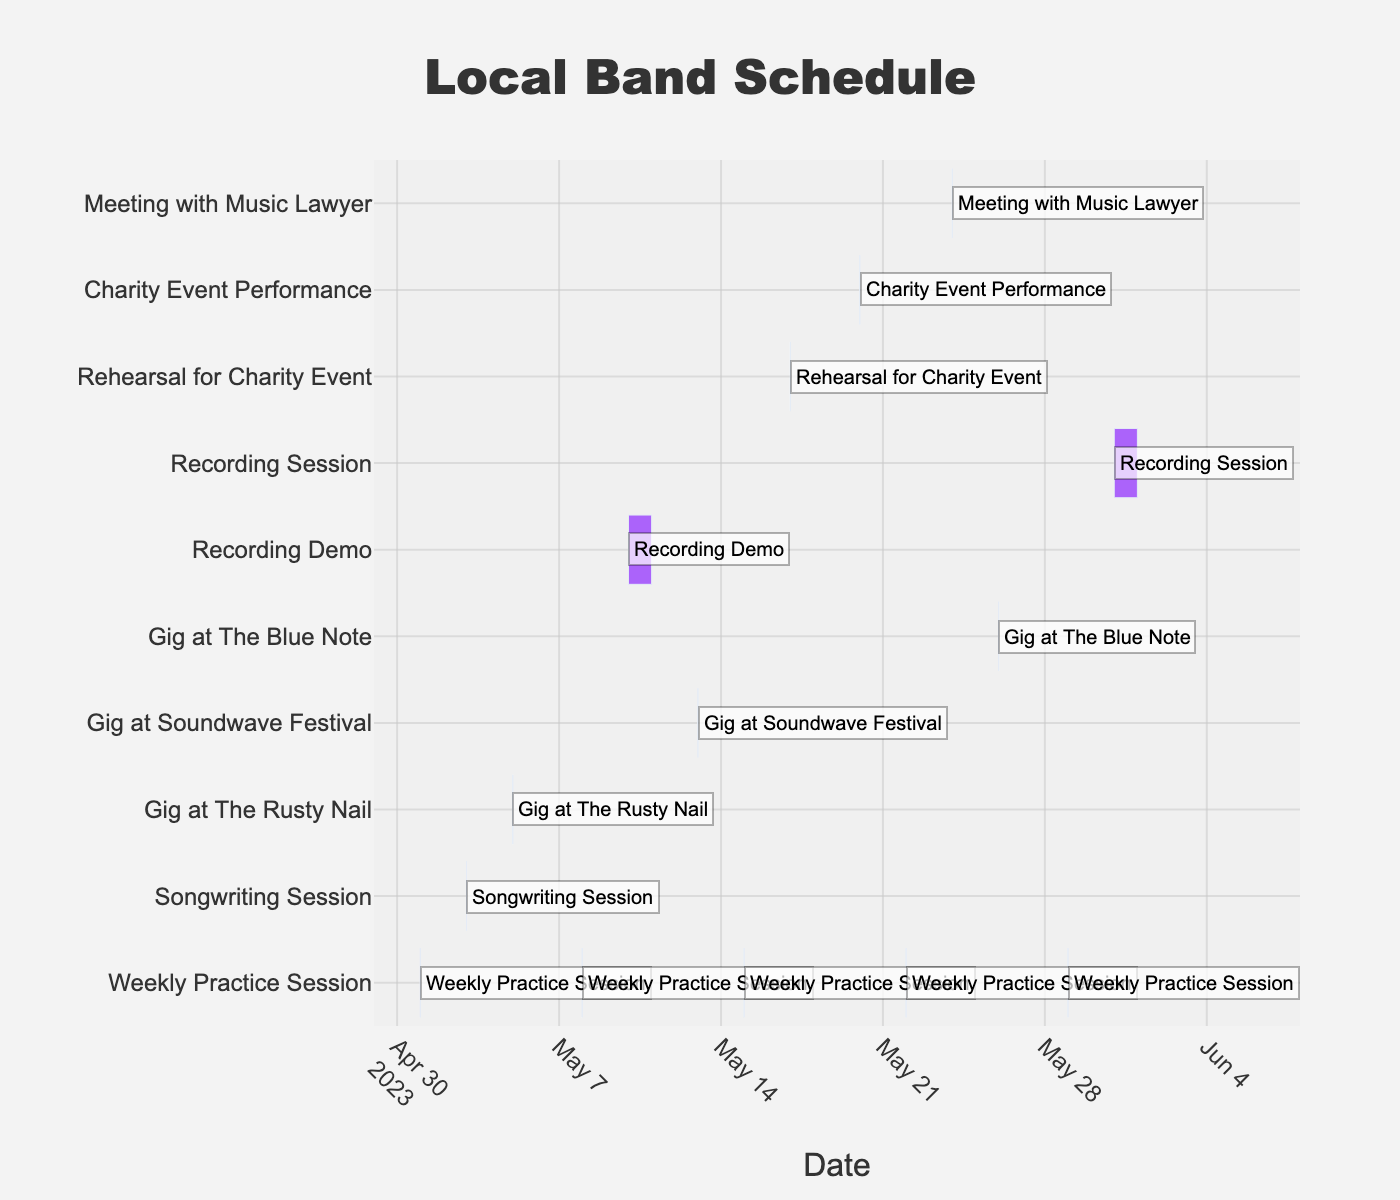What is the title of the chart? The title is located at the top center of the chart and is typically displayed in a larger and bolder font.
Answer: Local Band Schedule What is the color used for 'Weekly Practice Session'? By referring to the color of the bars associated with 'Weekly Practice Session', you can see they all share the same color.
Answer: Blue How many gig performances are scheduled in May? Look for bars with 'Gig' in their name and count them. The chart shows "Gig at The Rusty Nail", "Gig at Soundwave Festival", and "Gig at The Blue Note".
Answer: 3 Which session spans the longest duration? Identify the task with the longest horizontal bar in the timeline. The bars representing "Recording Demo" and "Recording Session" are the longest, each spanning two days.
Answer: Recording Demo and Recording Session On which date is the Charity Event Performance scheduled? Look for the bar labeled 'Charity Event Performance' and note its position on the timeline.
Answer: May 20, 2023 How many different types of tasks are listed in the schedule? Count the unique types of tasks (ignoring duplicates). There are 'Weekly Practice Session', 'Songwriting Session', 'Gig', 'Recording', 'Rehearsal', 'Meeting', and 'Charity Event'.
Answer: 7 How many events occur after the recording demo (May 10-11)? Identify the events dated after the recording demo. They are: "Gig at Soundwave Festival", "Weekly Practice Session", "Rehearsal for Charity Event", "Charity Event Performance", "Weekly Practice Session", "Meeting with Music Lawyer", "Gig at The Blue Note", "Weekly Practice Session", and "Recording Session".
Answer: 9 Which comes first, 'Meeting with Music Lawyer' or 'Rehearsal for Charity Event'? Compare the positions of these two events on the timeline. 'Rehearsal for Charity Event' is on May 17 while 'Meeting with Music Lawyer' is on May 24.
Answer: Rehearsal for Charity Event What's the total number of practice sessions planned for May? Count the bars labeled 'Weekly Practice Session' in the timeline. There are practice sessions on May 1, 8, 15, 22, and 29.
Answer: 5 What tasks are scheduled on or around May 13? Check the timeline around May 13. On May 13, there is "Gig at Soundwave Festival", with the closest tasks being "Recording Demo" just before and "Weekly Practice Session" just after.
Answer: Gig at Soundwave Festival, Recording Demo, and Weekly Practice Session 